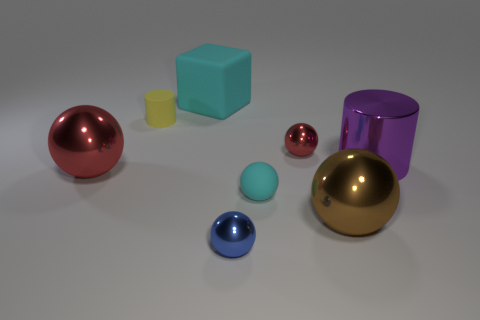What is the size of the metallic ball that is right of the cyan sphere and in front of the big red sphere?
Offer a terse response. Large. Is the number of yellow matte cylinders that are left of the purple thing greater than the number of small rubber cylinders in front of the large red metal sphere?
Give a very brief answer. Yes. There is another matte object that is the same shape as the blue thing; what color is it?
Ensure brevity in your answer.  Cyan. There is a small matte thing that is on the right side of the blue sphere; does it have the same color as the large rubber cube?
Your response must be concise. Yes. What number of rubber balls are there?
Your answer should be compact. 1. Does the big ball on the left side of the tiny blue object have the same material as the blue thing?
Give a very brief answer. Yes. How many tiny matte balls are in front of the cylinder in front of the matte object left of the big cyan thing?
Offer a terse response. 1. How big is the cyan cube?
Keep it short and to the point. Large. Do the rubber ball and the big matte thing have the same color?
Give a very brief answer. Yes. How big is the red sphere behind the big purple thing?
Keep it short and to the point. Small. 